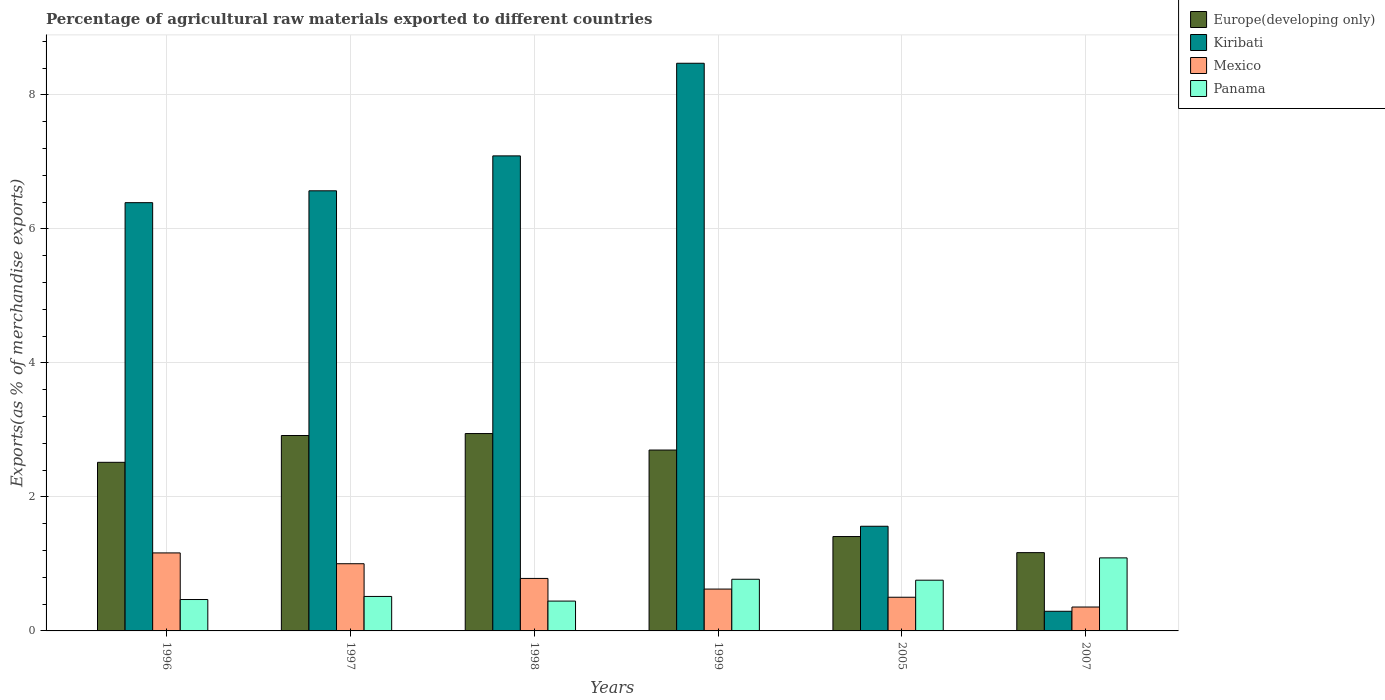How many different coloured bars are there?
Your response must be concise. 4. Are the number of bars per tick equal to the number of legend labels?
Your answer should be compact. Yes. Are the number of bars on each tick of the X-axis equal?
Give a very brief answer. Yes. How many bars are there on the 2nd tick from the left?
Your answer should be very brief. 4. How many bars are there on the 1st tick from the right?
Keep it short and to the point. 4. In how many cases, is the number of bars for a given year not equal to the number of legend labels?
Keep it short and to the point. 0. What is the percentage of exports to different countries in Mexico in 1999?
Your answer should be very brief. 0.62. Across all years, what is the maximum percentage of exports to different countries in Panama?
Offer a terse response. 1.09. Across all years, what is the minimum percentage of exports to different countries in Kiribati?
Provide a succinct answer. 0.29. In which year was the percentage of exports to different countries in Europe(developing only) minimum?
Provide a succinct answer. 2007. What is the total percentage of exports to different countries in Mexico in the graph?
Your answer should be very brief. 4.43. What is the difference between the percentage of exports to different countries in Panama in 1998 and that in 2007?
Provide a short and direct response. -0.64. What is the difference between the percentage of exports to different countries in Europe(developing only) in 2007 and the percentage of exports to different countries in Kiribati in 2005?
Your answer should be very brief. -0.39. What is the average percentage of exports to different countries in Kiribati per year?
Offer a very short reply. 5.06. In the year 1996, what is the difference between the percentage of exports to different countries in Mexico and percentage of exports to different countries in Panama?
Ensure brevity in your answer.  0.7. In how many years, is the percentage of exports to different countries in Europe(developing only) greater than 2 %?
Offer a terse response. 4. What is the ratio of the percentage of exports to different countries in Mexico in 1996 to that in 2007?
Your answer should be very brief. 3.26. What is the difference between the highest and the second highest percentage of exports to different countries in Europe(developing only)?
Give a very brief answer. 0.03. What is the difference between the highest and the lowest percentage of exports to different countries in Mexico?
Keep it short and to the point. 0.81. In how many years, is the percentage of exports to different countries in Europe(developing only) greater than the average percentage of exports to different countries in Europe(developing only) taken over all years?
Give a very brief answer. 4. Is the sum of the percentage of exports to different countries in Europe(developing only) in 1997 and 1999 greater than the maximum percentage of exports to different countries in Panama across all years?
Offer a very short reply. Yes. Is it the case that in every year, the sum of the percentage of exports to different countries in Mexico and percentage of exports to different countries in Panama is greater than the sum of percentage of exports to different countries in Europe(developing only) and percentage of exports to different countries in Kiribati?
Your answer should be compact. Yes. What does the 4th bar from the left in 1996 represents?
Make the answer very short. Panama. What does the 1st bar from the right in 1998 represents?
Your answer should be very brief. Panama. How many bars are there?
Provide a succinct answer. 24. What is the title of the graph?
Your answer should be very brief. Percentage of agricultural raw materials exported to different countries. What is the label or title of the Y-axis?
Offer a very short reply. Exports(as % of merchandise exports). What is the Exports(as % of merchandise exports) of Europe(developing only) in 1996?
Offer a very short reply. 2.52. What is the Exports(as % of merchandise exports) in Kiribati in 1996?
Your response must be concise. 6.39. What is the Exports(as % of merchandise exports) in Mexico in 1996?
Your answer should be compact. 1.16. What is the Exports(as % of merchandise exports) of Panama in 1996?
Provide a succinct answer. 0.47. What is the Exports(as % of merchandise exports) of Europe(developing only) in 1997?
Your answer should be very brief. 2.92. What is the Exports(as % of merchandise exports) in Kiribati in 1997?
Your response must be concise. 6.57. What is the Exports(as % of merchandise exports) in Mexico in 1997?
Make the answer very short. 1. What is the Exports(as % of merchandise exports) of Panama in 1997?
Your answer should be very brief. 0.51. What is the Exports(as % of merchandise exports) of Europe(developing only) in 1998?
Ensure brevity in your answer.  2.95. What is the Exports(as % of merchandise exports) in Kiribati in 1998?
Your answer should be compact. 7.09. What is the Exports(as % of merchandise exports) in Mexico in 1998?
Provide a short and direct response. 0.78. What is the Exports(as % of merchandise exports) in Panama in 1998?
Your answer should be compact. 0.45. What is the Exports(as % of merchandise exports) in Europe(developing only) in 1999?
Your response must be concise. 2.7. What is the Exports(as % of merchandise exports) in Kiribati in 1999?
Offer a terse response. 8.47. What is the Exports(as % of merchandise exports) of Mexico in 1999?
Give a very brief answer. 0.62. What is the Exports(as % of merchandise exports) of Panama in 1999?
Offer a terse response. 0.77. What is the Exports(as % of merchandise exports) in Europe(developing only) in 2005?
Offer a very short reply. 1.41. What is the Exports(as % of merchandise exports) in Kiribati in 2005?
Make the answer very short. 1.56. What is the Exports(as % of merchandise exports) in Mexico in 2005?
Provide a short and direct response. 0.5. What is the Exports(as % of merchandise exports) in Panama in 2005?
Give a very brief answer. 0.76. What is the Exports(as % of merchandise exports) in Europe(developing only) in 2007?
Offer a terse response. 1.17. What is the Exports(as % of merchandise exports) of Kiribati in 2007?
Ensure brevity in your answer.  0.29. What is the Exports(as % of merchandise exports) of Mexico in 2007?
Your answer should be very brief. 0.36. What is the Exports(as % of merchandise exports) of Panama in 2007?
Your answer should be very brief. 1.09. Across all years, what is the maximum Exports(as % of merchandise exports) of Europe(developing only)?
Offer a terse response. 2.95. Across all years, what is the maximum Exports(as % of merchandise exports) in Kiribati?
Offer a very short reply. 8.47. Across all years, what is the maximum Exports(as % of merchandise exports) in Mexico?
Offer a terse response. 1.16. Across all years, what is the maximum Exports(as % of merchandise exports) of Panama?
Ensure brevity in your answer.  1.09. Across all years, what is the minimum Exports(as % of merchandise exports) of Europe(developing only)?
Your answer should be very brief. 1.17. Across all years, what is the minimum Exports(as % of merchandise exports) of Kiribati?
Keep it short and to the point. 0.29. Across all years, what is the minimum Exports(as % of merchandise exports) in Mexico?
Provide a succinct answer. 0.36. Across all years, what is the minimum Exports(as % of merchandise exports) of Panama?
Provide a succinct answer. 0.45. What is the total Exports(as % of merchandise exports) of Europe(developing only) in the graph?
Give a very brief answer. 13.65. What is the total Exports(as % of merchandise exports) of Kiribati in the graph?
Offer a terse response. 30.37. What is the total Exports(as % of merchandise exports) of Mexico in the graph?
Give a very brief answer. 4.43. What is the total Exports(as % of merchandise exports) of Panama in the graph?
Keep it short and to the point. 4.05. What is the difference between the Exports(as % of merchandise exports) of Europe(developing only) in 1996 and that in 1997?
Your answer should be compact. -0.4. What is the difference between the Exports(as % of merchandise exports) of Kiribati in 1996 and that in 1997?
Provide a succinct answer. -0.18. What is the difference between the Exports(as % of merchandise exports) of Mexico in 1996 and that in 1997?
Your answer should be very brief. 0.16. What is the difference between the Exports(as % of merchandise exports) in Panama in 1996 and that in 1997?
Ensure brevity in your answer.  -0.05. What is the difference between the Exports(as % of merchandise exports) of Europe(developing only) in 1996 and that in 1998?
Offer a terse response. -0.43. What is the difference between the Exports(as % of merchandise exports) in Kiribati in 1996 and that in 1998?
Keep it short and to the point. -0.7. What is the difference between the Exports(as % of merchandise exports) of Mexico in 1996 and that in 1998?
Offer a very short reply. 0.38. What is the difference between the Exports(as % of merchandise exports) in Panama in 1996 and that in 1998?
Give a very brief answer. 0.02. What is the difference between the Exports(as % of merchandise exports) in Europe(developing only) in 1996 and that in 1999?
Your answer should be very brief. -0.18. What is the difference between the Exports(as % of merchandise exports) in Kiribati in 1996 and that in 1999?
Your response must be concise. -2.08. What is the difference between the Exports(as % of merchandise exports) in Mexico in 1996 and that in 1999?
Your answer should be compact. 0.54. What is the difference between the Exports(as % of merchandise exports) in Panama in 1996 and that in 1999?
Your answer should be compact. -0.3. What is the difference between the Exports(as % of merchandise exports) of Europe(developing only) in 1996 and that in 2005?
Provide a short and direct response. 1.11. What is the difference between the Exports(as % of merchandise exports) in Kiribati in 1996 and that in 2005?
Ensure brevity in your answer.  4.83. What is the difference between the Exports(as % of merchandise exports) of Mexico in 1996 and that in 2005?
Your response must be concise. 0.66. What is the difference between the Exports(as % of merchandise exports) in Panama in 1996 and that in 2005?
Keep it short and to the point. -0.29. What is the difference between the Exports(as % of merchandise exports) in Europe(developing only) in 1996 and that in 2007?
Offer a very short reply. 1.35. What is the difference between the Exports(as % of merchandise exports) of Kiribati in 1996 and that in 2007?
Your answer should be compact. 6.1. What is the difference between the Exports(as % of merchandise exports) in Mexico in 1996 and that in 2007?
Make the answer very short. 0.81. What is the difference between the Exports(as % of merchandise exports) in Panama in 1996 and that in 2007?
Give a very brief answer. -0.62. What is the difference between the Exports(as % of merchandise exports) of Europe(developing only) in 1997 and that in 1998?
Keep it short and to the point. -0.03. What is the difference between the Exports(as % of merchandise exports) of Kiribati in 1997 and that in 1998?
Make the answer very short. -0.52. What is the difference between the Exports(as % of merchandise exports) of Mexico in 1997 and that in 1998?
Make the answer very short. 0.22. What is the difference between the Exports(as % of merchandise exports) in Panama in 1997 and that in 1998?
Give a very brief answer. 0.07. What is the difference between the Exports(as % of merchandise exports) of Europe(developing only) in 1997 and that in 1999?
Offer a very short reply. 0.22. What is the difference between the Exports(as % of merchandise exports) of Kiribati in 1997 and that in 1999?
Offer a terse response. -1.9. What is the difference between the Exports(as % of merchandise exports) in Mexico in 1997 and that in 1999?
Provide a short and direct response. 0.38. What is the difference between the Exports(as % of merchandise exports) of Panama in 1997 and that in 1999?
Your answer should be compact. -0.26. What is the difference between the Exports(as % of merchandise exports) of Europe(developing only) in 1997 and that in 2005?
Ensure brevity in your answer.  1.51. What is the difference between the Exports(as % of merchandise exports) of Kiribati in 1997 and that in 2005?
Give a very brief answer. 5.01. What is the difference between the Exports(as % of merchandise exports) in Mexico in 1997 and that in 2005?
Keep it short and to the point. 0.5. What is the difference between the Exports(as % of merchandise exports) in Panama in 1997 and that in 2005?
Your response must be concise. -0.24. What is the difference between the Exports(as % of merchandise exports) in Europe(developing only) in 1997 and that in 2007?
Offer a terse response. 1.75. What is the difference between the Exports(as % of merchandise exports) in Kiribati in 1997 and that in 2007?
Keep it short and to the point. 6.27. What is the difference between the Exports(as % of merchandise exports) of Mexico in 1997 and that in 2007?
Offer a very short reply. 0.65. What is the difference between the Exports(as % of merchandise exports) in Panama in 1997 and that in 2007?
Make the answer very short. -0.58. What is the difference between the Exports(as % of merchandise exports) in Europe(developing only) in 1998 and that in 1999?
Offer a very short reply. 0.25. What is the difference between the Exports(as % of merchandise exports) in Kiribati in 1998 and that in 1999?
Offer a very short reply. -1.38. What is the difference between the Exports(as % of merchandise exports) of Mexico in 1998 and that in 1999?
Give a very brief answer. 0.16. What is the difference between the Exports(as % of merchandise exports) of Panama in 1998 and that in 1999?
Provide a succinct answer. -0.33. What is the difference between the Exports(as % of merchandise exports) in Europe(developing only) in 1998 and that in 2005?
Offer a terse response. 1.54. What is the difference between the Exports(as % of merchandise exports) in Kiribati in 1998 and that in 2005?
Make the answer very short. 5.53. What is the difference between the Exports(as % of merchandise exports) in Mexico in 1998 and that in 2005?
Offer a very short reply. 0.28. What is the difference between the Exports(as % of merchandise exports) of Panama in 1998 and that in 2005?
Give a very brief answer. -0.31. What is the difference between the Exports(as % of merchandise exports) in Europe(developing only) in 1998 and that in 2007?
Your response must be concise. 1.78. What is the difference between the Exports(as % of merchandise exports) of Kiribati in 1998 and that in 2007?
Make the answer very short. 6.8. What is the difference between the Exports(as % of merchandise exports) of Mexico in 1998 and that in 2007?
Offer a very short reply. 0.43. What is the difference between the Exports(as % of merchandise exports) of Panama in 1998 and that in 2007?
Provide a short and direct response. -0.64. What is the difference between the Exports(as % of merchandise exports) in Europe(developing only) in 1999 and that in 2005?
Your answer should be very brief. 1.29. What is the difference between the Exports(as % of merchandise exports) of Kiribati in 1999 and that in 2005?
Provide a succinct answer. 6.91. What is the difference between the Exports(as % of merchandise exports) of Mexico in 1999 and that in 2005?
Provide a short and direct response. 0.12. What is the difference between the Exports(as % of merchandise exports) of Panama in 1999 and that in 2005?
Keep it short and to the point. 0.01. What is the difference between the Exports(as % of merchandise exports) of Europe(developing only) in 1999 and that in 2007?
Provide a short and direct response. 1.53. What is the difference between the Exports(as % of merchandise exports) of Kiribati in 1999 and that in 2007?
Offer a terse response. 8.18. What is the difference between the Exports(as % of merchandise exports) in Mexico in 1999 and that in 2007?
Provide a succinct answer. 0.27. What is the difference between the Exports(as % of merchandise exports) in Panama in 1999 and that in 2007?
Your answer should be compact. -0.32. What is the difference between the Exports(as % of merchandise exports) in Europe(developing only) in 2005 and that in 2007?
Provide a succinct answer. 0.24. What is the difference between the Exports(as % of merchandise exports) of Kiribati in 2005 and that in 2007?
Offer a terse response. 1.27. What is the difference between the Exports(as % of merchandise exports) in Mexico in 2005 and that in 2007?
Provide a succinct answer. 0.15. What is the difference between the Exports(as % of merchandise exports) in Panama in 2005 and that in 2007?
Keep it short and to the point. -0.33. What is the difference between the Exports(as % of merchandise exports) of Europe(developing only) in 1996 and the Exports(as % of merchandise exports) of Kiribati in 1997?
Your answer should be compact. -4.05. What is the difference between the Exports(as % of merchandise exports) of Europe(developing only) in 1996 and the Exports(as % of merchandise exports) of Mexico in 1997?
Make the answer very short. 1.51. What is the difference between the Exports(as % of merchandise exports) in Europe(developing only) in 1996 and the Exports(as % of merchandise exports) in Panama in 1997?
Give a very brief answer. 2. What is the difference between the Exports(as % of merchandise exports) of Kiribati in 1996 and the Exports(as % of merchandise exports) of Mexico in 1997?
Offer a terse response. 5.39. What is the difference between the Exports(as % of merchandise exports) in Kiribati in 1996 and the Exports(as % of merchandise exports) in Panama in 1997?
Make the answer very short. 5.88. What is the difference between the Exports(as % of merchandise exports) of Mexico in 1996 and the Exports(as % of merchandise exports) of Panama in 1997?
Your answer should be compact. 0.65. What is the difference between the Exports(as % of merchandise exports) of Europe(developing only) in 1996 and the Exports(as % of merchandise exports) of Kiribati in 1998?
Give a very brief answer. -4.57. What is the difference between the Exports(as % of merchandise exports) in Europe(developing only) in 1996 and the Exports(as % of merchandise exports) in Mexico in 1998?
Provide a short and direct response. 1.73. What is the difference between the Exports(as % of merchandise exports) in Europe(developing only) in 1996 and the Exports(as % of merchandise exports) in Panama in 1998?
Your answer should be compact. 2.07. What is the difference between the Exports(as % of merchandise exports) of Kiribati in 1996 and the Exports(as % of merchandise exports) of Mexico in 1998?
Your answer should be compact. 5.61. What is the difference between the Exports(as % of merchandise exports) in Kiribati in 1996 and the Exports(as % of merchandise exports) in Panama in 1998?
Provide a succinct answer. 5.95. What is the difference between the Exports(as % of merchandise exports) in Mexico in 1996 and the Exports(as % of merchandise exports) in Panama in 1998?
Offer a terse response. 0.72. What is the difference between the Exports(as % of merchandise exports) in Europe(developing only) in 1996 and the Exports(as % of merchandise exports) in Kiribati in 1999?
Offer a terse response. -5.96. What is the difference between the Exports(as % of merchandise exports) of Europe(developing only) in 1996 and the Exports(as % of merchandise exports) of Mexico in 1999?
Offer a very short reply. 1.89. What is the difference between the Exports(as % of merchandise exports) of Europe(developing only) in 1996 and the Exports(as % of merchandise exports) of Panama in 1999?
Offer a very short reply. 1.75. What is the difference between the Exports(as % of merchandise exports) of Kiribati in 1996 and the Exports(as % of merchandise exports) of Mexico in 1999?
Ensure brevity in your answer.  5.77. What is the difference between the Exports(as % of merchandise exports) in Kiribati in 1996 and the Exports(as % of merchandise exports) in Panama in 1999?
Give a very brief answer. 5.62. What is the difference between the Exports(as % of merchandise exports) in Mexico in 1996 and the Exports(as % of merchandise exports) in Panama in 1999?
Your response must be concise. 0.39. What is the difference between the Exports(as % of merchandise exports) of Europe(developing only) in 1996 and the Exports(as % of merchandise exports) of Kiribati in 2005?
Your response must be concise. 0.95. What is the difference between the Exports(as % of merchandise exports) in Europe(developing only) in 1996 and the Exports(as % of merchandise exports) in Mexico in 2005?
Keep it short and to the point. 2.01. What is the difference between the Exports(as % of merchandise exports) of Europe(developing only) in 1996 and the Exports(as % of merchandise exports) of Panama in 2005?
Keep it short and to the point. 1.76. What is the difference between the Exports(as % of merchandise exports) in Kiribati in 1996 and the Exports(as % of merchandise exports) in Mexico in 2005?
Your response must be concise. 5.89. What is the difference between the Exports(as % of merchandise exports) of Kiribati in 1996 and the Exports(as % of merchandise exports) of Panama in 2005?
Ensure brevity in your answer.  5.63. What is the difference between the Exports(as % of merchandise exports) of Mexico in 1996 and the Exports(as % of merchandise exports) of Panama in 2005?
Give a very brief answer. 0.41. What is the difference between the Exports(as % of merchandise exports) in Europe(developing only) in 1996 and the Exports(as % of merchandise exports) in Kiribati in 2007?
Your answer should be very brief. 2.22. What is the difference between the Exports(as % of merchandise exports) of Europe(developing only) in 1996 and the Exports(as % of merchandise exports) of Mexico in 2007?
Offer a very short reply. 2.16. What is the difference between the Exports(as % of merchandise exports) of Europe(developing only) in 1996 and the Exports(as % of merchandise exports) of Panama in 2007?
Provide a succinct answer. 1.43. What is the difference between the Exports(as % of merchandise exports) of Kiribati in 1996 and the Exports(as % of merchandise exports) of Mexico in 2007?
Keep it short and to the point. 6.03. What is the difference between the Exports(as % of merchandise exports) in Kiribati in 1996 and the Exports(as % of merchandise exports) in Panama in 2007?
Your response must be concise. 5.3. What is the difference between the Exports(as % of merchandise exports) in Mexico in 1996 and the Exports(as % of merchandise exports) in Panama in 2007?
Ensure brevity in your answer.  0.07. What is the difference between the Exports(as % of merchandise exports) in Europe(developing only) in 1997 and the Exports(as % of merchandise exports) in Kiribati in 1998?
Your answer should be very brief. -4.17. What is the difference between the Exports(as % of merchandise exports) of Europe(developing only) in 1997 and the Exports(as % of merchandise exports) of Mexico in 1998?
Make the answer very short. 2.13. What is the difference between the Exports(as % of merchandise exports) of Europe(developing only) in 1997 and the Exports(as % of merchandise exports) of Panama in 1998?
Ensure brevity in your answer.  2.47. What is the difference between the Exports(as % of merchandise exports) in Kiribati in 1997 and the Exports(as % of merchandise exports) in Mexico in 1998?
Offer a very short reply. 5.78. What is the difference between the Exports(as % of merchandise exports) in Kiribati in 1997 and the Exports(as % of merchandise exports) in Panama in 1998?
Your response must be concise. 6.12. What is the difference between the Exports(as % of merchandise exports) in Mexico in 1997 and the Exports(as % of merchandise exports) in Panama in 1998?
Offer a very short reply. 0.56. What is the difference between the Exports(as % of merchandise exports) of Europe(developing only) in 1997 and the Exports(as % of merchandise exports) of Kiribati in 1999?
Your response must be concise. -5.55. What is the difference between the Exports(as % of merchandise exports) of Europe(developing only) in 1997 and the Exports(as % of merchandise exports) of Mexico in 1999?
Provide a succinct answer. 2.29. What is the difference between the Exports(as % of merchandise exports) in Europe(developing only) in 1997 and the Exports(as % of merchandise exports) in Panama in 1999?
Provide a succinct answer. 2.15. What is the difference between the Exports(as % of merchandise exports) in Kiribati in 1997 and the Exports(as % of merchandise exports) in Mexico in 1999?
Keep it short and to the point. 5.94. What is the difference between the Exports(as % of merchandise exports) in Kiribati in 1997 and the Exports(as % of merchandise exports) in Panama in 1999?
Your response must be concise. 5.8. What is the difference between the Exports(as % of merchandise exports) of Mexico in 1997 and the Exports(as % of merchandise exports) of Panama in 1999?
Your answer should be compact. 0.23. What is the difference between the Exports(as % of merchandise exports) of Europe(developing only) in 1997 and the Exports(as % of merchandise exports) of Kiribati in 2005?
Provide a succinct answer. 1.35. What is the difference between the Exports(as % of merchandise exports) in Europe(developing only) in 1997 and the Exports(as % of merchandise exports) in Mexico in 2005?
Your answer should be very brief. 2.41. What is the difference between the Exports(as % of merchandise exports) of Europe(developing only) in 1997 and the Exports(as % of merchandise exports) of Panama in 2005?
Offer a very short reply. 2.16. What is the difference between the Exports(as % of merchandise exports) of Kiribati in 1997 and the Exports(as % of merchandise exports) of Mexico in 2005?
Offer a terse response. 6.07. What is the difference between the Exports(as % of merchandise exports) in Kiribati in 1997 and the Exports(as % of merchandise exports) in Panama in 2005?
Keep it short and to the point. 5.81. What is the difference between the Exports(as % of merchandise exports) in Mexico in 1997 and the Exports(as % of merchandise exports) in Panama in 2005?
Offer a terse response. 0.25. What is the difference between the Exports(as % of merchandise exports) of Europe(developing only) in 1997 and the Exports(as % of merchandise exports) of Kiribati in 2007?
Your answer should be very brief. 2.62. What is the difference between the Exports(as % of merchandise exports) in Europe(developing only) in 1997 and the Exports(as % of merchandise exports) in Mexico in 2007?
Provide a succinct answer. 2.56. What is the difference between the Exports(as % of merchandise exports) of Europe(developing only) in 1997 and the Exports(as % of merchandise exports) of Panama in 2007?
Your answer should be compact. 1.83. What is the difference between the Exports(as % of merchandise exports) in Kiribati in 1997 and the Exports(as % of merchandise exports) in Mexico in 2007?
Offer a terse response. 6.21. What is the difference between the Exports(as % of merchandise exports) of Kiribati in 1997 and the Exports(as % of merchandise exports) of Panama in 2007?
Offer a terse response. 5.48. What is the difference between the Exports(as % of merchandise exports) of Mexico in 1997 and the Exports(as % of merchandise exports) of Panama in 2007?
Provide a succinct answer. -0.09. What is the difference between the Exports(as % of merchandise exports) in Europe(developing only) in 1998 and the Exports(as % of merchandise exports) in Kiribati in 1999?
Keep it short and to the point. -5.53. What is the difference between the Exports(as % of merchandise exports) in Europe(developing only) in 1998 and the Exports(as % of merchandise exports) in Mexico in 1999?
Make the answer very short. 2.32. What is the difference between the Exports(as % of merchandise exports) of Europe(developing only) in 1998 and the Exports(as % of merchandise exports) of Panama in 1999?
Make the answer very short. 2.17. What is the difference between the Exports(as % of merchandise exports) of Kiribati in 1998 and the Exports(as % of merchandise exports) of Mexico in 1999?
Give a very brief answer. 6.46. What is the difference between the Exports(as % of merchandise exports) of Kiribati in 1998 and the Exports(as % of merchandise exports) of Panama in 1999?
Give a very brief answer. 6.32. What is the difference between the Exports(as % of merchandise exports) in Mexico in 1998 and the Exports(as % of merchandise exports) in Panama in 1999?
Make the answer very short. 0.01. What is the difference between the Exports(as % of merchandise exports) of Europe(developing only) in 1998 and the Exports(as % of merchandise exports) of Kiribati in 2005?
Your answer should be compact. 1.38. What is the difference between the Exports(as % of merchandise exports) of Europe(developing only) in 1998 and the Exports(as % of merchandise exports) of Mexico in 2005?
Your answer should be compact. 2.44. What is the difference between the Exports(as % of merchandise exports) in Europe(developing only) in 1998 and the Exports(as % of merchandise exports) in Panama in 2005?
Your answer should be compact. 2.19. What is the difference between the Exports(as % of merchandise exports) in Kiribati in 1998 and the Exports(as % of merchandise exports) in Mexico in 2005?
Your answer should be very brief. 6.59. What is the difference between the Exports(as % of merchandise exports) of Kiribati in 1998 and the Exports(as % of merchandise exports) of Panama in 2005?
Provide a short and direct response. 6.33. What is the difference between the Exports(as % of merchandise exports) in Mexico in 1998 and the Exports(as % of merchandise exports) in Panama in 2005?
Keep it short and to the point. 0.03. What is the difference between the Exports(as % of merchandise exports) of Europe(developing only) in 1998 and the Exports(as % of merchandise exports) of Kiribati in 2007?
Offer a very short reply. 2.65. What is the difference between the Exports(as % of merchandise exports) of Europe(developing only) in 1998 and the Exports(as % of merchandise exports) of Mexico in 2007?
Offer a very short reply. 2.59. What is the difference between the Exports(as % of merchandise exports) in Europe(developing only) in 1998 and the Exports(as % of merchandise exports) in Panama in 2007?
Make the answer very short. 1.86. What is the difference between the Exports(as % of merchandise exports) of Kiribati in 1998 and the Exports(as % of merchandise exports) of Mexico in 2007?
Make the answer very short. 6.73. What is the difference between the Exports(as % of merchandise exports) in Kiribati in 1998 and the Exports(as % of merchandise exports) in Panama in 2007?
Your answer should be compact. 6. What is the difference between the Exports(as % of merchandise exports) in Mexico in 1998 and the Exports(as % of merchandise exports) in Panama in 2007?
Your response must be concise. -0.31. What is the difference between the Exports(as % of merchandise exports) in Europe(developing only) in 1999 and the Exports(as % of merchandise exports) in Kiribati in 2005?
Make the answer very short. 1.14. What is the difference between the Exports(as % of merchandise exports) in Europe(developing only) in 1999 and the Exports(as % of merchandise exports) in Mexico in 2005?
Your answer should be very brief. 2.2. What is the difference between the Exports(as % of merchandise exports) of Europe(developing only) in 1999 and the Exports(as % of merchandise exports) of Panama in 2005?
Offer a very short reply. 1.94. What is the difference between the Exports(as % of merchandise exports) of Kiribati in 1999 and the Exports(as % of merchandise exports) of Mexico in 2005?
Ensure brevity in your answer.  7.97. What is the difference between the Exports(as % of merchandise exports) of Kiribati in 1999 and the Exports(as % of merchandise exports) of Panama in 2005?
Keep it short and to the point. 7.71. What is the difference between the Exports(as % of merchandise exports) of Mexico in 1999 and the Exports(as % of merchandise exports) of Panama in 2005?
Give a very brief answer. -0.13. What is the difference between the Exports(as % of merchandise exports) of Europe(developing only) in 1999 and the Exports(as % of merchandise exports) of Kiribati in 2007?
Offer a terse response. 2.41. What is the difference between the Exports(as % of merchandise exports) of Europe(developing only) in 1999 and the Exports(as % of merchandise exports) of Mexico in 2007?
Provide a short and direct response. 2.34. What is the difference between the Exports(as % of merchandise exports) of Europe(developing only) in 1999 and the Exports(as % of merchandise exports) of Panama in 2007?
Provide a succinct answer. 1.61. What is the difference between the Exports(as % of merchandise exports) in Kiribati in 1999 and the Exports(as % of merchandise exports) in Mexico in 2007?
Make the answer very short. 8.11. What is the difference between the Exports(as % of merchandise exports) of Kiribati in 1999 and the Exports(as % of merchandise exports) of Panama in 2007?
Give a very brief answer. 7.38. What is the difference between the Exports(as % of merchandise exports) of Mexico in 1999 and the Exports(as % of merchandise exports) of Panama in 2007?
Ensure brevity in your answer.  -0.47. What is the difference between the Exports(as % of merchandise exports) in Europe(developing only) in 2005 and the Exports(as % of merchandise exports) in Kiribati in 2007?
Ensure brevity in your answer.  1.12. What is the difference between the Exports(as % of merchandise exports) of Europe(developing only) in 2005 and the Exports(as % of merchandise exports) of Mexico in 2007?
Ensure brevity in your answer.  1.05. What is the difference between the Exports(as % of merchandise exports) of Europe(developing only) in 2005 and the Exports(as % of merchandise exports) of Panama in 2007?
Keep it short and to the point. 0.32. What is the difference between the Exports(as % of merchandise exports) in Kiribati in 2005 and the Exports(as % of merchandise exports) in Mexico in 2007?
Make the answer very short. 1.21. What is the difference between the Exports(as % of merchandise exports) in Kiribati in 2005 and the Exports(as % of merchandise exports) in Panama in 2007?
Provide a short and direct response. 0.47. What is the difference between the Exports(as % of merchandise exports) of Mexico in 2005 and the Exports(as % of merchandise exports) of Panama in 2007?
Provide a succinct answer. -0.59. What is the average Exports(as % of merchandise exports) of Europe(developing only) per year?
Keep it short and to the point. 2.28. What is the average Exports(as % of merchandise exports) in Kiribati per year?
Make the answer very short. 5.06. What is the average Exports(as % of merchandise exports) in Mexico per year?
Your response must be concise. 0.74. What is the average Exports(as % of merchandise exports) of Panama per year?
Your answer should be compact. 0.67. In the year 1996, what is the difference between the Exports(as % of merchandise exports) in Europe(developing only) and Exports(as % of merchandise exports) in Kiribati?
Offer a terse response. -3.87. In the year 1996, what is the difference between the Exports(as % of merchandise exports) in Europe(developing only) and Exports(as % of merchandise exports) in Mexico?
Keep it short and to the point. 1.35. In the year 1996, what is the difference between the Exports(as % of merchandise exports) in Europe(developing only) and Exports(as % of merchandise exports) in Panama?
Offer a terse response. 2.05. In the year 1996, what is the difference between the Exports(as % of merchandise exports) of Kiribati and Exports(as % of merchandise exports) of Mexico?
Your response must be concise. 5.23. In the year 1996, what is the difference between the Exports(as % of merchandise exports) of Kiribati and Exports(as % of merchandise exports) of Panama?
Give a very brief answer. 5.92. In the year 1996, what is the difference between the Exports(as % of merchandise exports) of Mexico and Exports(as % of merchandise exports) of Panama?
Offer a terse response. 0.7. In the year 1997, what is the difference between the Exports(as % of merchandise exports) in Europe(developing only) and Exports(as % of merchandise exports) in Kiribati?
Make the answer very short. -3.65. In the year 1997, what is the difference between the Exports(as % of merchandise exports) of Europe(developing only) and Exports(as % of merchandise exports) of Mexico?
Keep it short and to the point. 1.91. In the year 1997, what is the difference between the Exports(as % of merchandise exports) in Europe(developing only) and Exports(as % of merchandise exports) in Panama?
Your answer should be very brief. 2.4. In the year 1997, what is the difference between the Exports(as % of merchandise exports) in Kiribati and Exports(as % of merchandise exports) in Mexico?
Provide a succinct answer. 5.56. In the year 1997, what is the difference between the Exports(as % of merchandise exports) of Kiribati and Exports(as % of merchandise exports) of Panama?
Your answer should be very brief. 6.05. In the year 1997, what is the difference between the Exports(as % of merchandise exports) of Mexico and Exports(as % of merchandise exports) of Panama?
Offer a terse response. 0.49. In the year 1998, what is the difference between the Exports(as % of merchandise exports) of Europe(developing only) and Exports(as % of merchandise exports) of Kiribati?
Make the answer very short. -4.14. In the year 1998, what is the difference between the Exports(as % of merchandise exports) in Europe(developing only) and Exports(as % of merchandise exports) in Mexico?
Keep it short and to the point. 2.16. In the year 1998, what is the difference between the Exports(as % of merchandise exports) of Europe(developing only) and Exports(as % of merchandise exports) of Panama?
Your answer should be compact. 2.5. In the year 1998, what is the difference between the Exports(as % of merchandise exports) in Kiribati and Exports(as % of merchandise exports) in Mexico?
Your answer should be very brief. 6.31. In the year 1998, what is the difference between the Exports(as % of merchandise exports) of Kiribati and Exports(as % of merchandise exports) of Panama?
Provide a succinct answer. 6.64. In the year 1998, what is the difference between the Exports(as % of merchandise exports) of Mexico and Exports(as % of merchandise exports) of Panama?
Offer a terse response. 0.34. In the year 1999, what is the difference between the Exports(as % of merchandise exports) of Europe(developing only) and Exports(as % of merchandise exports) of Kiribati?
Your response must be concise. -5.77. In the year 1999, what is the difference between the Exports(as % of merchandise exports) in Europe(developing only) and Exports(as % of merchandise exports) in Mexico?
Give a very brief answer. 2.07. In the year 1999, what is the difference between the Exports(as % of merchandise exports) in Europe(developing only) and Exports(as % of merchandise exports) in Panama?
Provide a succinct answer. 1.93. In the year 1999, what is the difference between the Exports(as % of merchandise exports) in Kiribati and Exports(as % of merchandise exports) in Mexico?
Give a very brief answer. 7.85. In the year 1999, what is the difference between the Exports(as % of merchandise exports) in Mexico and Exports(as % of merchandise exports) in Panama?
Your answer should be very brief. -0.15. In the year 2005, what is the difference between the Exports(as % of merchandise exports) of Europe(developing only) and Exports(as % of merchandise exports) of Kiribati?
Ensure brevity in your answer.  -0.15. In the year 2005, what is the difference between the Exports(as % of merchandise exports) of Europe(developing only) and Exports(as % of merchandise exports) of Mexico?
Offer a very short reply. 0.91. In the year 2005, what is the difference between the Exports(as % of merchandise exports) of Europe(developing only) and Exports(as % of merchandise exports) of Panama?
Give a very brief answer. 0.65. In the year 2005, what is the difference between the Exports(as % of merchandise exports) in Kiribati and Exports(as % of merchandise exports) in Mexico?
Your answer should be compact. 1.06. In the year 2005, what is the difference between the Exports(as % of merchandise exports) of Kiribati and Exports(as % of merchandise exports) of Panama?
Offer a very short reply. 0.8. In the year 2005, what is the difference between the Exports(as % of merchandise exports) of Mexico and Exports(as % of merchandise exports) of Panama?
Provide a short and direct response. -0.25. In the year 2007, what is the difference between the Exports(as % of merchandise exports) of Europe(developing only) and Exports(as % of merchandise exports) of Mexico?
Give a very brief answer. 0.81. In the year 2007, what is the difference between the Exports(as % of merchandise exports) of Europe(developing only) and Exports(as % of merchandise exports) of Panama?
Keep it short and to the point. 0.08. In the year 2007, what is the difference between the Exports(as % of merchandise exports) in Kiribati and Exports(as % of merchandise exports) in Mexico?
Offer a terse response. -0.06. In the year 2007, what is the difference between the Exports(as % of merchandise exports) of Kiribati and Exports(as % of merchandise exports) of Panama?
Your answer should be very brief. -0.8. In the year 2007, what is the difference between the Exports(as % of merchandise exports) of Mexico and Exports(as % of merchandise exports) of Panama?
Provide a short and direct response. -0.73. What is the ratio of the Exports(as % of merchandise exports) in Europe(developing only) in 1996 to that in 1997?
Your answer should be very brief. 0.86. What is the ratio of the Exports(as % of merchandise exports) in Kiribati in 1996 to that in 1997?
Your response must be concise. 0.97. What is the ratio of the Exports(as % of merchandise exports) of Mexico in 1996 to that in 1997?
Your response must be concise. 1.16. What is the ratio of the Exports(as % of merchandise exports) in Panama in 1996 to that in 1997?
Your answer should be very brief. 0.91. What is the ratio of the Exports(as % of merchandise exports) in Europe(developing only) in 1996 to that in 1998?
Your answer should be compact. 0.85. What is the ratio of the Exports(as % of merchandise exports) of Kiribati in 1996 to that in 1998?
Offer a very short reply. 0.9. What is the ratio of the Exports(as % of merchandise exports) of Mexico in 1996 to that in 1998?
Give a very brief answer. 1.49. What is the ratio of the Exports(as % of merchandise exports) of Panama in 1996 to that in 1998?
Your answer should be compact. 1.05. What is the ratio of the Exports(as % of merchandise exports) in Europe(developing only) in 1996 to that in 1999?
Your answer should be compact. 0.93. What is the ratio of the Exports(as % of merchandise exports) in Kiribati in 1996 to that in 1999?
Your answer should be very brief. 0.75. What is the ratio of the Exports(as % of merchandise exports) of Mexico in 1996 to that in 1999?
Keep it short and to the point. 1.86. What is the ratio of the Exports(as % of merchandise exports) in Panama in 1996 to that in 1999?
Your answer should be compact. 0.61. What is the ratio of the Exports(as % of merchandise exports) in Europe(developing only) in 1996 to that in 2005?
Your response must be concise. 1.79. What is the ratio of the Exports(as % of merchandise exports) in Kiribati in 1996 to that in 2005?
Provide a short and direct response. 4.09. What is the ratio of the Exports(as % of merchandise exports) in Mexico in 1996 to that in 2005?
Give a very brief answer. 2.32. What is the ratio of the Exports(as % of merchandise exports) in Panama in 1996 to that in 2005?
Ensure brevity in your answer.  0.62. What is the ratio of the Exports(as % of merchandise exports) in Europe(developing only) in 1996 to that in 2007?
Keep it short and to the point. 2.15. What is the ratio of the Exports(as % of merchandise exports) of Kiribati in 1996 to that in 2007?
Ensure brevity in your answer.  21.8. What is the ratio of the Exports(as % of merchandise exports) of Mexico in 1996 to that in 2007?
Provide a succinct answer. 3.26. What is the ratio of the Exports(as % of merchandise exports) in Panama in 1996 to that in 2007?
Give a very brief answer. 0.43. What is the ratio of the Exports(as % of merchandise exports) of Kiribati in 1997 to that in 1998?
Your response must be concise. 0.93. What is the ratio of the Exports(as % of merchandise exports) in Mexico in 1997 to that in 1998?
Offer a terse response. 1.28. What is the ratio of the Exports(as % of merchandise exports) of Panama in 1997 to that in 1998?
Your answer should be very brief. 1.16. What is the ratio of the Exports(as % of merchandise exports) in Europe(developing only) in 1997 to that in 1999?
Ensure brevity in your answer.  1.08. What is the ratio of the Exports(as % of merchandise exports) of Kiribati in 1997 to that in 1999?
Provide a succinct answer. 0.78. What is the ratio of the Exports(as % of merchandise exports) of Mexico in 1997 to that in 1999?
Your answer should be compact. 1.61. What is the ratio of the Exports(as % of merchandise exports) of Panama in 1997 to that in 1999?
Ensure brevity in your answer.  0.67. What is the ratio of the Exports(as % of merchandise exports) of Europe(developing only) in 1997 to that in 2005?
Make the answer very short. 2.07. What is the ratio of the Exports(as % of merchandise exports) in Kiribati in 1997 to that in 2005?
Offer a terse response. 4.21. What is the ratio of the Exports(as % of merchandise exports) of Mexico in 1997 to that in 2005?
Make the answer very short. 2. What is the ratio of the Exports(as % of merchandise exports) in Panama in 1997 to that in 2005?
Give a very brief answer. 0.68. What is the ratio of the Exports(as % of merchandise exports) in Europe(developing only) in 1997 to that in 2007?
Keep it short and to the point. 2.5. What is the ratio of the Exports(as % of merchandise exports) in Kiribati in 1997 to that in 2007?
Provide a succinct answer. 22.4. What is the ratio of the Exports(as % of merchandise exports) of Mexico in 1997 to that in 2007?
Make the answer very short. 2.81. What is the ratio of the Exports(as % of merchandise exports) of Panama in 1997 to that in 2007?
Your answer should be very brief. 0.47. What is the ratio of the Exports(as % of merchandise exports) of Europe(developing only) in 1998 to that in 1999?
Give a very brief answer. 1.09. What is the ratio of the Exports(as % of merchandise exports) of Kiribati in 1998 to that in 1999?
Keep it short and to the point. 0.84. What is the ratio of the Exports(as % of merchandise exports) in Mexico in 1998 to that in 1999?
Your answer should be compact. 1.25. What is the ratio of the Exports(as % of merchandise exports) of Panama in 1998 to that in 1999?
Your answer should be compact. 0.58. What is the ratio of the Exports(as % of merchandise exports) of Europe(developing only) in 1998 to that in 2005?
Provide a short and direct response. 2.09. What is the ratio of the Exports(as % of merchandise exports) of Kiribati in 1998 to that in 2005?
Provide a succinct answer. 4.54. What is the ratio of the Exports(as % of merchandise exports) of Mexico in 1998 to that in 2005?
Ensure brevity in your answer.  1.56. What is the ratio of the Exports(as % of merchandise exports) of Panama in 1998 to that in 2005?
Offer a very short reply. 0.59. What is the ratio of the Exports(as % of merchandise exports) of Europe(developing only) in 1998 to that in 2007?
Your answer should be very brief. 2.52. What is the ratio of the Exports(as % of merchandise exports) in Kiribati in 1998 to that in 2007?
Give a very brief answer. 24.18. What is the ratio of the Exports(as % of merchandise exports) of Mexico in 1998 to that in 2007?
Give a very brief answer. 2.2. What is the ratio of the Exports(as % of merchandise exports) in Panama in 1998 to that in 2007?
Provide a short and direct response. 0.41. What is the ratio of the Exports(as % of merchandise exports) in Europe(developing only) in 1999 to that in 2005?
Your response must be concise. 1.92. What is the ratio of the Exports(as % of merchandise exports) in Kiribati in 1999 to that in 2005?
Ensure brevity in your answer.  5.42. What is the ratio of the Exports(as % of merchandise exports) in Mexico in 1999 to that in 2005?
Give a very brief answer. 1.24. What is the ratio of the Exports(as % of merchandise exports) in Panama in 1999 to that in 2005?
Provide a short and direct response. 1.02. What is the ratio of the Exports(as % of merchandise exports) in Europe(developing only) in 1999 to that in 2007?
Offer a very short reply. 2.31. What is the ratio of the Exports(as % of merchandise exports) in Kiribati in 1999 to that in 2007?
Make the answer very short. 28.89. What is the ratio of the Exports(as % of merchandise exports) in Mexico in 1999 to that in 2007?
Offer a terse response. 1.75. What is the ratio of the Exports(as % of merchandise exports) in Panama in 1999 to that in 2007?
Your answer should be compact. 0.71. What is the ratio of the Exports(as % of merchandise exports) in Europe(developing only) in 2005 to that in 2007?
Offer a terse response. 1.21. What is the ratio of the Exports(as % of merchandise exports) in Kiribati in 2005 to that in 2007?
Your answer should be compact. 5.33. What is the ratio of the Exports(as % of merchandise exports) in Mexico in 2005 to that in 2007?
Provide a succinct answer. 1.41. What is the ratio of the Exports(as % of merchandise exports) in Panama in 2005 to that in 2007?
Your response must be concise. 0.69. What is the difference between the highest and the second highest Exports(as % of merchandise exports) of Europe(developing only)?
Provide a short and direct response. 0.03. What is the difference between the highest and the second highest Exports(as % of merchandise exports) in Kiribati?
Keep it short and to the point. 1.38. What is the difference between the highest and the second highest Exports(as % of merchandise exports) in Mexico?
Your answer should be compact. 0.16. What is the difference between the highest and the second highest Exports(as % of merchandise exports) of Panama?
Your response must be concise. 0.32. What is the difference between the highest and the lowest Exports(as % of merchandise exports) of Europe(developing only)?
Give a very brief answer. 1.78. What is the difference between the highest and the lowest Exports(as % of merchandise exports) in Kiribati?
Ensure brevity in your answer.  8.18. What is the difference between the highest and the lowest Exports(as % of merchandise exports) of Mexico?
Give a very brief answer. 0.81. What is the difference between the highest and the lowest Exports(as % of merchandise exports) of Panama?
Your answer should be very brief. 0.64. 